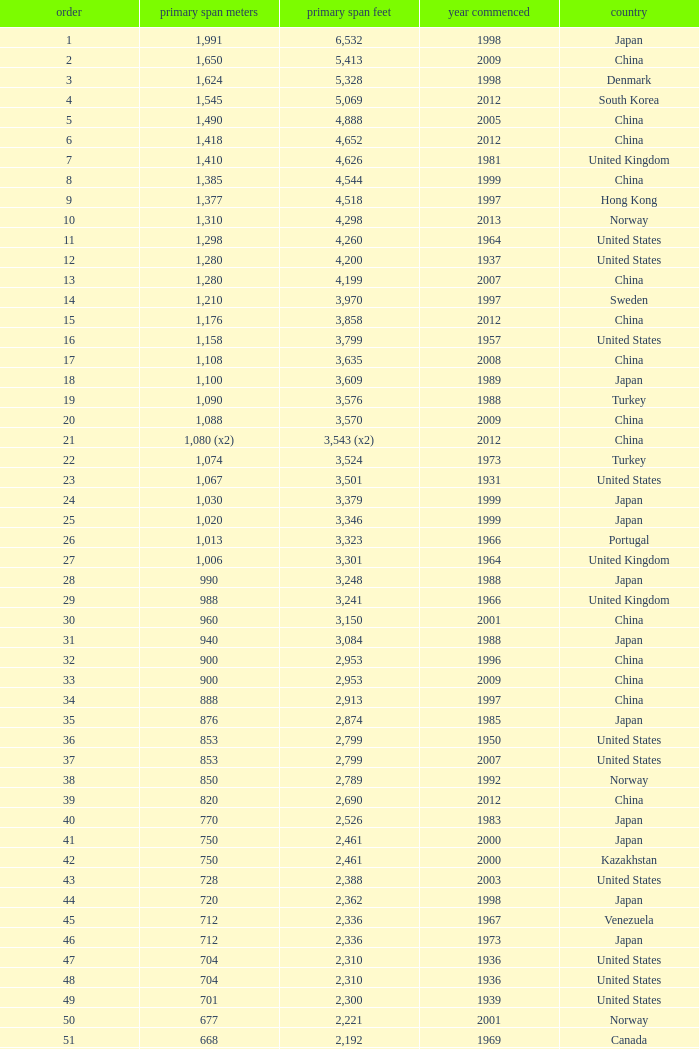Parse the full table. {'header': ['order', 'primary span meters', 'primary span feet', 'year commenced', 'country'], 'rows': [['1', '1,991', '6,532', '1998', 'Japan'], ['2', '1,650', '5,413', '2009', 'China'], ['3', '1,624', '5,328', '1998', 'Denmark'], ['4', '1,545', '5,069', '2012', 'South Korea'], ['5', '1,490', '4,888', '2005', 'China'], ['6', '1,418', '4,652', '2012', 'China'], ['7', '1,410', '4,626', '1981', 'United Kingdom'], ['8', '1,385', '4,544', '1999', 'China'], ['9', '1,377', '4,518', '1997', 'Hong Kong'], ['10', '1,310', '4,298', '2013', 'Norway'], ['11', '1,298', '4,260', '1964', 'United States'], ['12', '1,280', '4,200', '1937', 'United States'], ['13', '1,280', '4,199', '2007', 'China'], ['14', '1,210', '3,970', '1997', 'Sweden'], ['15', '1,176', '3,858', '2012', 'China'], ['16', '1,158', '3,799', '1957', 'United States'], ['17', '1,108', '3,635', '2008', 'China'], ['18', '1,100', '3,609', '1989', 'Japan'], ['19', '1,090', '3,576', '1988', 'Turkey'], ['20', '1,088', '3,570', '2009', 'China'], ['21', '1,080 (x2)', '3,543 (x2)', '2012', 'China'], ['22', '1,074', '3,524', '1973', 'Turkey'], ['23', '1,067', '3,501', '1931', 'United States'], ['24', '1,030', '3,379', '1999', 'Japan'], ['25', '1,020', '3,346', '1999', 'Japan'], ['26', '1,013', '3,323', '1966', 'Portugal'], ['27', '1,006', '3,301', '1964', 'United Kingdom'], ['28', '990', '3,248', '1988', 'Japan'], ['29', '988', '3,241', '1966', 'United Kingdom'], ['30', '960', '3,150', '2001', 'China'], ['31', '940', '3,084', '1988', 'Japan'], ['32', '900', '2,953', '1996', 'China'], ['33', '900', '2,953', '2009', 'China'], ['34', '888', '2,913', '1997', 'China'], ['35', '876', '2,874', '1985', 'Japan'], ['36', '853', '2,799', '1950', 'United States'], ['37', '853', '2,799', '2007', 'United States'], ['38', '850', '2,789', '1992', 'Norway'], ['39', '820', '2,690', '2012', 'China'], ['40', '770', '2,526', '1983', 'Japan'], ['41', '750', '2,461', '2000', 'Japan'], ['42', '750', '2,461', '2000', 'Kazakhstan'], ['43', '728', '2,388', '2003', 'United States'], ['44', '720', '2,362', '1998', 'Japan'], ['45', '712', '2,336', '1967', 'Venezuela'], ['46', '712', '2,336', '1973', 'Japan'], ['47', '704', '2,310', '1936', 'United States'], ['48', '704', '2,310', '1936', 'United States'], ['49', '701', '2,300', '1939', 'United States'], ['50', '677', '2,221', '2001', 'Norway'], ['51', '668', '2,192', '1969', 'Canada'], ['52', '656', '2,152', '1968', 'United States'], ['53', '656', '2152', '1951', 'United States'], ['54', '648', '2,126', '1999', 'China'], ['55', '636', '2,087', '2009', 'China'], ['56', '623', '2,044', '1992', 'Norway'], ['57', '616', '2,021', '2009', 'China'], ['58', '610', '2,001', '1957', 'United States'], ['59', '608', '1,995', '1959', 'France'], ['60', '600', '1,969', '1970', 'Denmark'], ['61', '600', '1,969', '1999', 'Japan'], ['62', '600', '1,969', '2000', 'China'], ['63', '595', '1,952', '1997', 'Norway'], ['64', '580', '1,903', '2003', 'China'], ['65', '577', '1,893', '2001', 'Norway'], ['66', '570', '1,870', '1993', 'Japan'], ['67', '564', '1,850', '1929', 'United States Canada'], ['68', '560', '1,837', '1988', 'Japan'], ['69', '560', '1,837', '2001', 'China'], ['70', '549', '1,801', '1961', 'United States'], ['71', '540', '1,772', '2008', 'Japan'], ['72', '534', '1,752', '1926', 'United States'], ['73', '525', '1,722', '1972', 'Norway'], ['74', '525', '1,722', '1977', 'Norway'], ['75', '520', '1,706', '1983', 'Democratic Republic of the Congo'], ['76', '500', '1,640', '1965', 'Germany'], ['77', '500', '1,640', '2002', 'South Korea'], ['78', '497', '1,631', '1924', 'United States'], ['79', '488', '1,601', '1903', 'United States'], ['80', '488', '1,601', '1969', 'United States'], ['81', '488', '1,601', '1952', 'United States'], ['82', '488', '1,601', '1973', 'United States'], ['83', '486', '1,594', '1883', 'United States'], ['84', '473', '1,552', '1938', 'Canada'], ['85', '468', '1,535', '1971', 'Norway'], ['86', '465', '1,526', '1977', 'Japan'], ['87', '457', '1,499', '1930', 'United States'], ['88', '457', '1,499', '1963', 'United States'], ['89', '452', '1,483', '1995', 'China'], ['90', '450', '1,476', '1997', 'China'], ['91', '448', '1,470', '1909', 'United States'], ['92', '446', '1,463', '1997', 'Norway'], ['93', '441', '1,447', '1955', 'Canada'], ['94', '430', '1,411', '2012', 'China'], ['95', '427', '1,401', '1970', 'Canada'], ['96', '421', '1,381', '1936', 'United States'], ['97', '417', '1,368', '1966', 'Sweden'], ['98', '408', '1339', '2010', 'China'], ['99', '405', '1,329', '2009', 'Vietnam'], ['100', '404', '1,325', '1973', 'South Korea'], ['101', '394', '1,293', '1967', 'France'], ['102', '390', '1,280', '1964', 'Uzbekistan'], ['103', '385', '1,263', '2013', 'United States'], ['104', '378', '1,240', '1954', 'Germany'], ['105', '368', '1,207', '1931', 'United States'], ['106', '367', '1,204', '1962', 'Japan'], ['107', '366', '1,200', '1929', 'United States'], ['108', '351', '1,151', '1960', 'United States Canada'], ['109', '350', '1,148', '2006', 'China'], ['110', '340', '1,115', '1926', 'Brazil'], ['111', '338', '1,109', '2001', 'China'], ['112', '338', '1,108', '1965', 'United States'], ['113', '337', '1,106', '1956', 'Norway'], ['114', '335', '1,100', '1961', 'United Kingdom'], ['115', '335', '1,100', '2006', 'Norway'], ['116', '329', '1,088', '1939', 'United States'], ['117', '328', '1,085', '1939', 'Zambia Zimbabwe'], ['118', '325', '1,066', '1964', 'Norway'], ['119', '325', '1,066', '1981', 'Norway'], ['120', '323', '1,060', '1932', 'United States'], ['121', '323', '1,059', '1936', 'Canada'], ['122', '322', '1,057', '1867', 'United States'], ['123', '320', '1,050', '1971', 'United States'], ['124', '320', '1,050', '2011', 'Peru'], ['125', '315', '1,033', '1951', 'Germany'], ['126', '308', '1,010', '1849', 'United States'], ['127', '300', '985', '1961', 'Canada'], ['128', '300', '984', '1987', 'Japan'], ['129', '300', '984', '2000', 'France'], ['130', '300', '984', '2000', 'South Korea']]} What is the main span in feet from a year of 2009 or more recent with a rank less than 94 and 1,310 main span metres? 4298.0. 